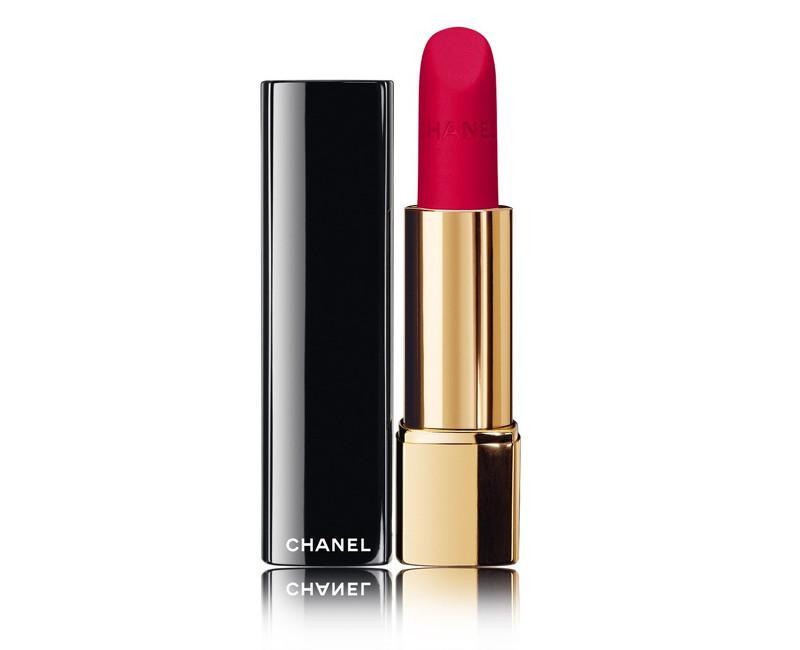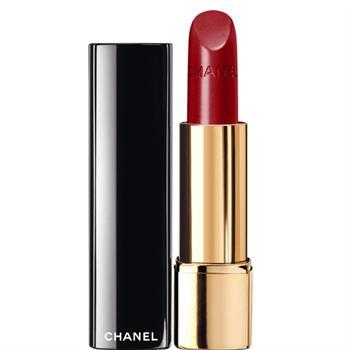The first image is the image on the left, the second image is the image on the right. Assess this claim about the two images: "An image includes one exposed lipstick wand and no tube lipsticks.". Correct or not? Answer yes or no. No. The first image is the image on the left, the second image is the image on the right. Assess this claim about the two images: "One of the images shows a foam-tipped lip applicator.". Correct or not? Answer yes or no. No. 